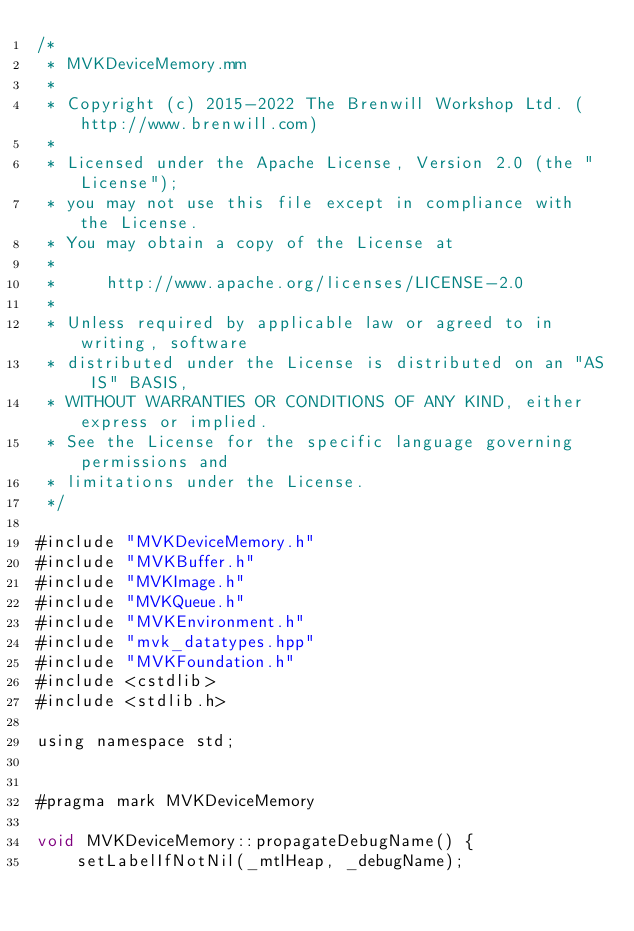Convert code to text. <code><loc_0><loc_0><loc_500><loc_500><_ObjectiveC_>/*
 * MVKDeviceMemory.mm
 *
 * Copyright (c) 2015-2022 The Brenwill Workshop Ltd. (http://www.brenwill.com)
 *
 * Licensed under the Apache License, Version 2.0 (the "License");
 * you may not use this file except in compliance with the License.
 * You may obtain a copy of the License at
 * 
 *     http://www.apache.org/licenses/LICENSE-2.0
 * 
 * Unless required by applicable law or agreed to in writing, software
 * distributed under the License is distributed on an "AS IS" BASIS,
 * WITHOUT WARRANTIES OR CONDITIONS OF ANY KIND, either express or implied.
 * See the License for the specific language governing permissions and
 * limitations under the License.
 */

#include "MVKDeviceMemory.h"
#include "MVKBuffer.h"
#include "MVKImage.h"
#include "MVKQueue.h"
#include "MVKEnvironment.h"
#include "mvk_datatypes.hpp"
#include "MVKFoundation.h"
#include <cstdlib>
#include <stdlib.h>

using namespace std;


#pragma mark MVKDeviceMemory

void MVKDeviceMemory::propagateDebugName() {
	setLabelIfNotNil(_mtlHeap, _debugName);</code> 